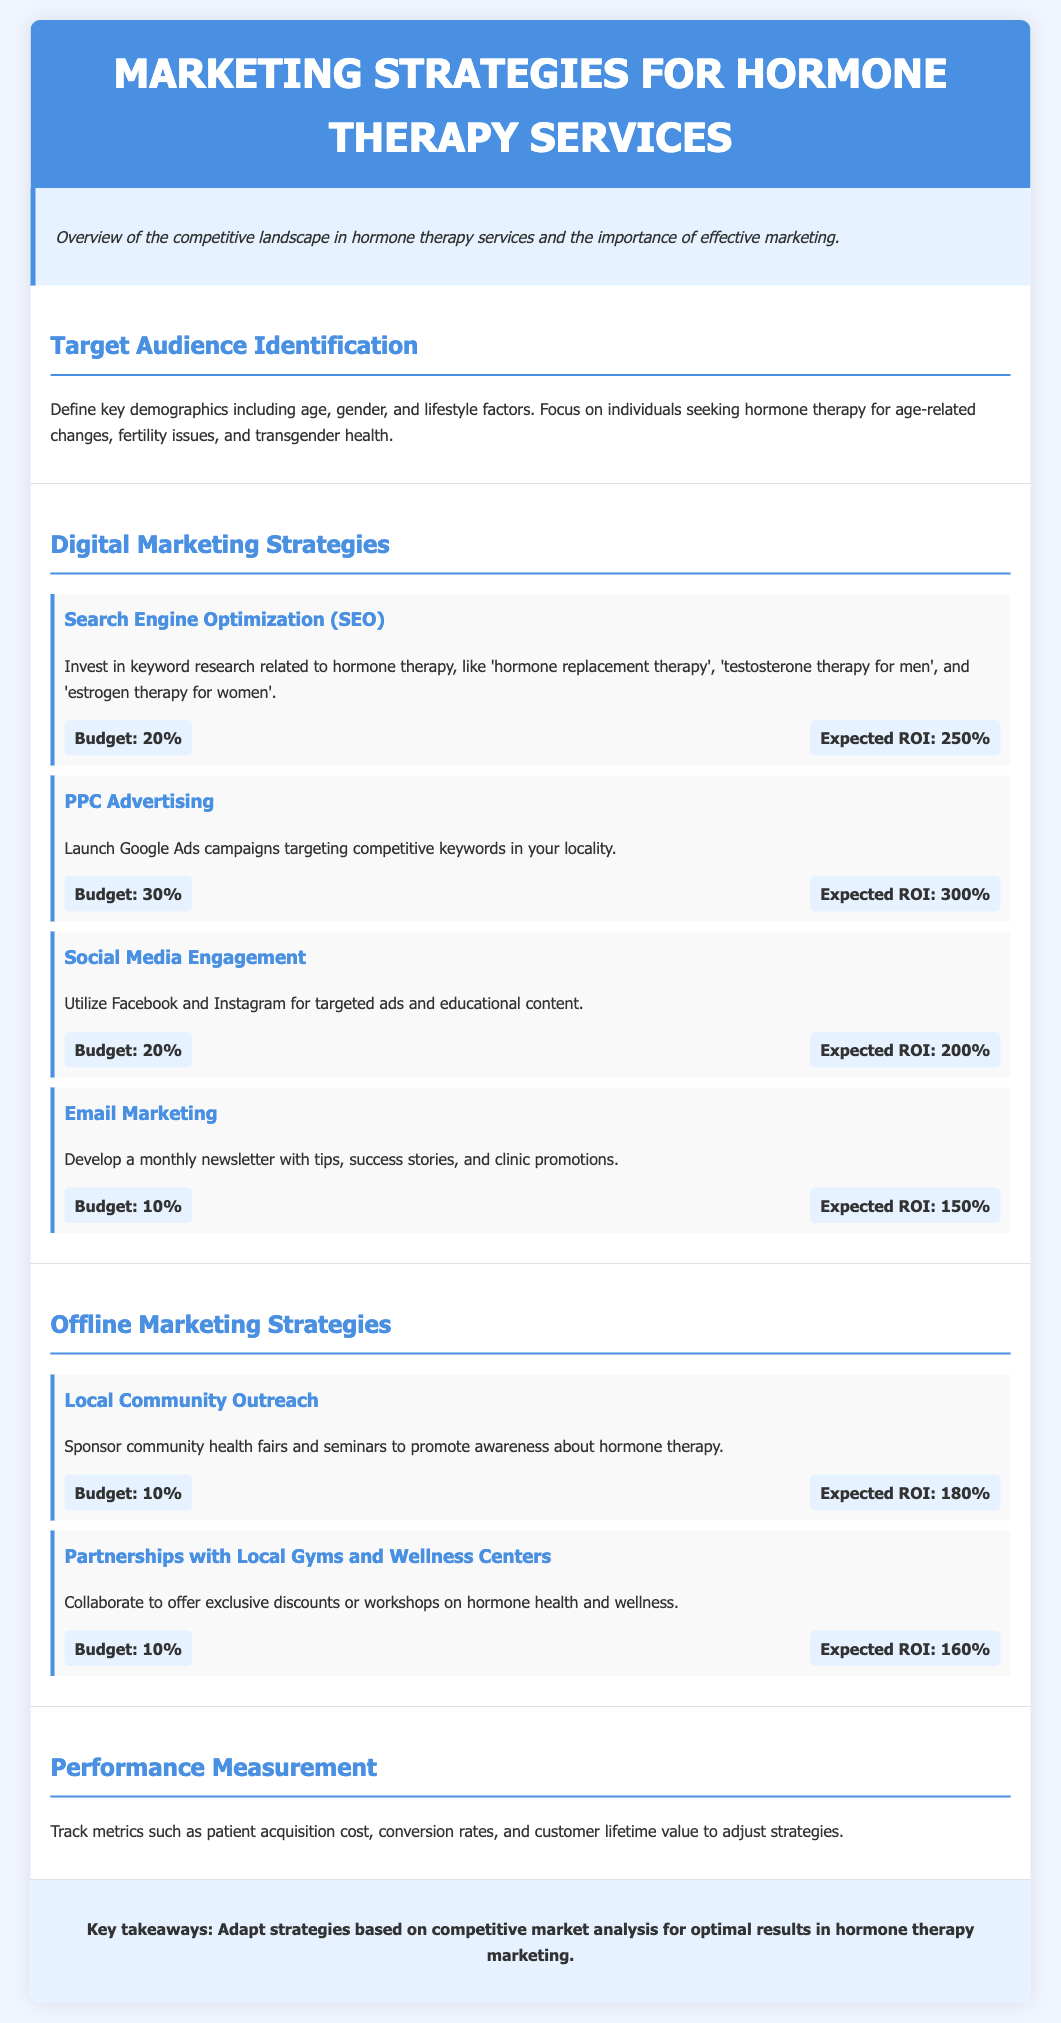What is the total budget allocation for digital marketing strategies? The budget allocation for digital marketing strategies is the sum of all percentages allocated to each digital strategy, which is 20% + 30% + 20% + 10% = 80%.
Answer: 80% What is the expected ROI for PPC Advertising? The expected ROI for PPC Advertising is listed under the metrics for that strategy, which is 300%.
Answer: 300% Which social media platform is mentioned for engagement? The document specifically mentions Facebook and Instagram for targeted ads and educational content in the social media engagement strategy.
Answer: Facebook and Instagram What is the budget percentage for Email Marketing? The document specifies that Email Marketing has a budget allocation of 10%.
Answer: 10% What is the purpose of local community outreach? The purpose of local community outreach is to promote awareness about hormone therapy according to the document.
Answer: Promote awareness What is the expected ROI for local community outreach? The expected ROI for Local Community Outreach is provided in the metrics section, which is 180%.
Answer: 180% How are "customer lifetime value" and "conversion rates" utilized according to the document? The document states that these metrics are tracked to adjust strategies for performance measurement.
Answer: Adjust strategies What is the overall theme of the document? The theme revolves around effective marketing strategies for hormone therapy services.
Answer: Marketing strategies What is the ROI for Social Media Engagement? The expected ROI for Social Media Engagement is listed as 200%.
Answer: 200% 